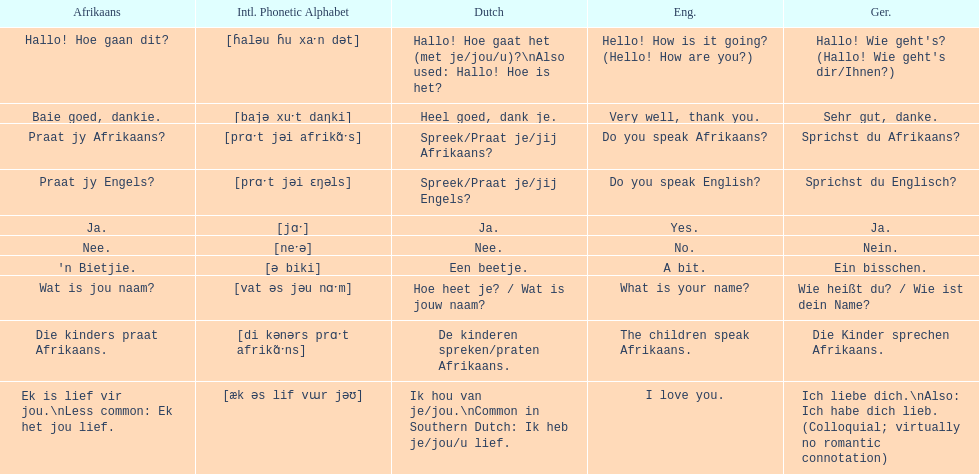What is the way to say 'do you speak afrikaans?' in afrikaans? Praat jy Afrikaans?. 